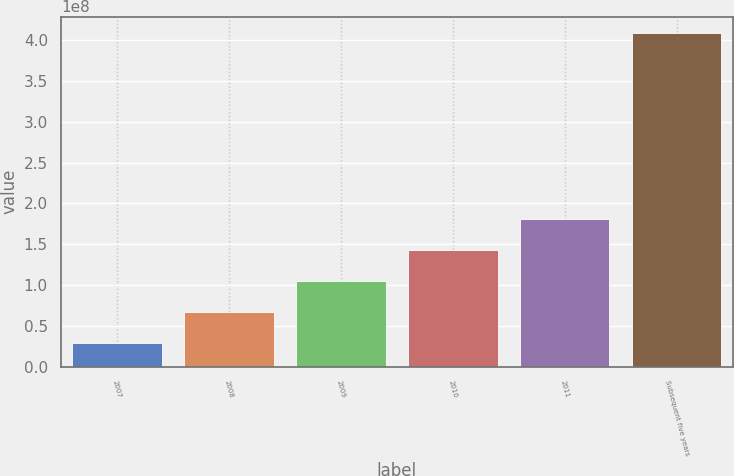Convert chart. <chart><loc_0><loc_0><loc_500><loc_500><bar_chart><fcel>2007<fcel>2008<fcel>2009<fcel>2010<fcel>2011<fcel>Subsequent five years<nl><fcel>2.9446e+07<fcel>6.73703e+07<fcel>1.05295e+08<fcel>1.43219e+08<fcel>1.81143e+08<fcel>4.08689e+08<nl></chart> 